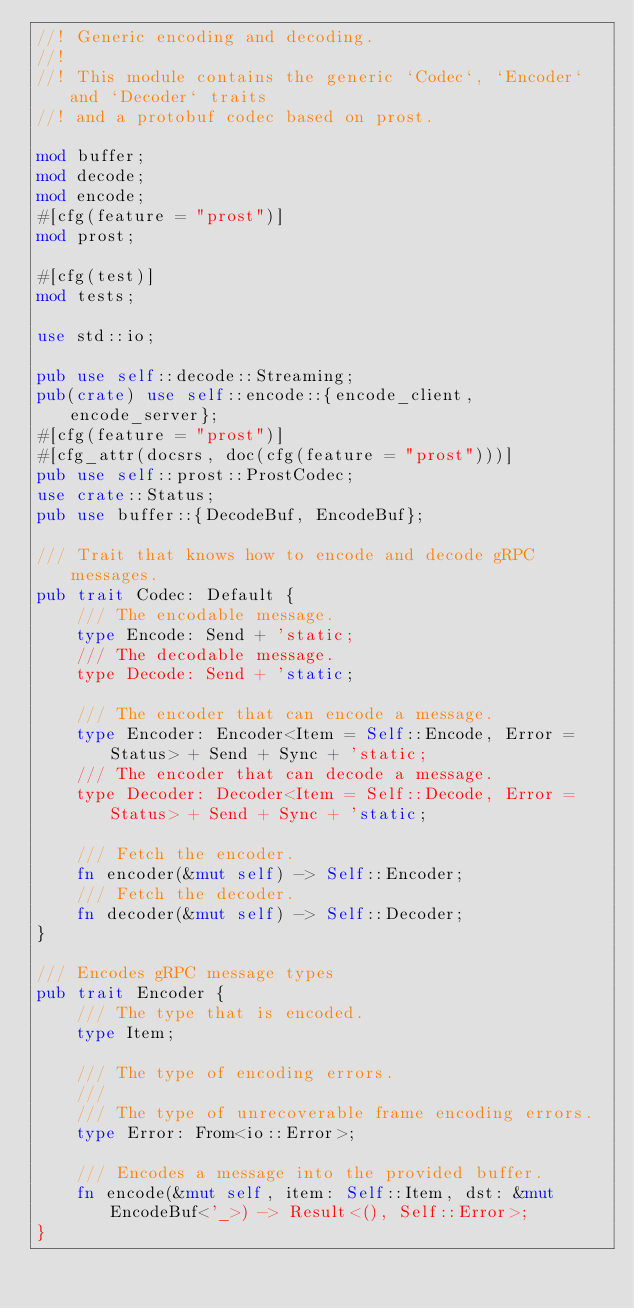<code> <loc_0><loc_0><loc_500><loc_500><_Rust_>//! Generic encoding and decoding.
//!
//! This module contains the generic `Codec`, `Encoder` and `Decoder` traits
//! and a protobuf codec based on prost.

mod buffer;
mod decode;
mod encode;
#[cfg(feature = "prost")]
mod prost;

#[cfg(test)]
mod tests;

use std::io;

pub use self::decode::Streaming;
pub(crate) use self::encode::{encode_client, encode_server};
#[cfg(feature = "prost")]
#[cfg_attr(docsrs, doc(cfg(feature = "prost")))]
pub use self::prost::ProstCodec;
use crate::Status;
pub use buffer::{DecodeBuf, EncodeBuf};

/// Trait that knows how to encode and decode gRPC messages.
pub trait Codec: Default {
    /// The encodable message.
    type Encode: Send + 'static;
    /// The decodable message.
    type Decode: Send + 'static;

    /// The encoder that can encode a message.
    type Encoder: Encoder<Item = Self::Encode, Error = Status> + Send + Sync + 'static;
    /// The encoder that can decode a message.
    type Decoder: Decoder<Item = Self::Decode, Error = Status> + Send + Sync + 'static;

    /// Fetch the encoder.
    fn encoder(&mut self) -> Self::Encoder;
    /// Fetch the decoder.
    fn decoder(&mut self) -> Self::Decoder;
}

/// Encodes gRPC message types
pub trait Encoder {
    /// The type that is encoded.
    type Item;

    /// The type of encoding errors.
    ///
    /// The type of unrecoverable frame encoding errors.
    type Error: From<io::Error>;

    /// Encodes a message into the provided buffer.
    fn encode(&mut self, item: Self::Item, dst: &mut EncodeBuf<'_>) -> Result<(), Self::Error>;
}
</code> 